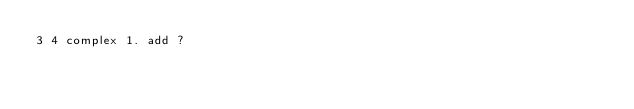<code> <loc_0><loc_0><loc_500><loc_500><_Perl_>3 4 complex 1. add ?
</code> 